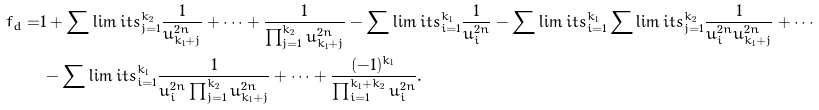<formula> <loc_0><loc_0><loc_500><loc_500>f _ { d } = & 1 + \sum \lim i t s _ { j = 1 } ^ { k _ { 2 } } \frac { 1 } { u _ { k _ { 1 } + j } ^ { 2 n } } + \cdots + \frac { 1 } { \prod _ { j = 1 } ^ { k _ { 2 } } u _ { k _ { 1 } + j } ^ { 2 n } } - \sum \lim i t s _ { i = 1 } ^ { k _ { 1 } } \frac { 1 } { u _ { i } ^ { 2 n } } - \sum \lim i t s _ { i = 1 } ^ { k _ { 1 } } \sum \lim i t s _ { j = 1 } ^ { k _ { 2 } } \frac { 1 } { u _ { i } ^ { 2 n } u _ { k _ { 1 } + j } ^ { 2 n } } + \cdots \\ & \, - \sum \lim i t s _ { i = 1 } ^ { k _ { 1 } } \frac { 1 } { u _ { i } ^ { 2 n } \prod _ { j = 1 } ^ { k _ { 2 } } u _ { k _ { 1 } + j } ^ { 2 n } } + \cdots + \frac { ( - 1 ) ^ { k _ { 1 } } } { \prod _ { i = 1 } ^ { k _ { 1 } + k _ { 2 } } u _ { i } ^ { 2 n } } .</formula> 